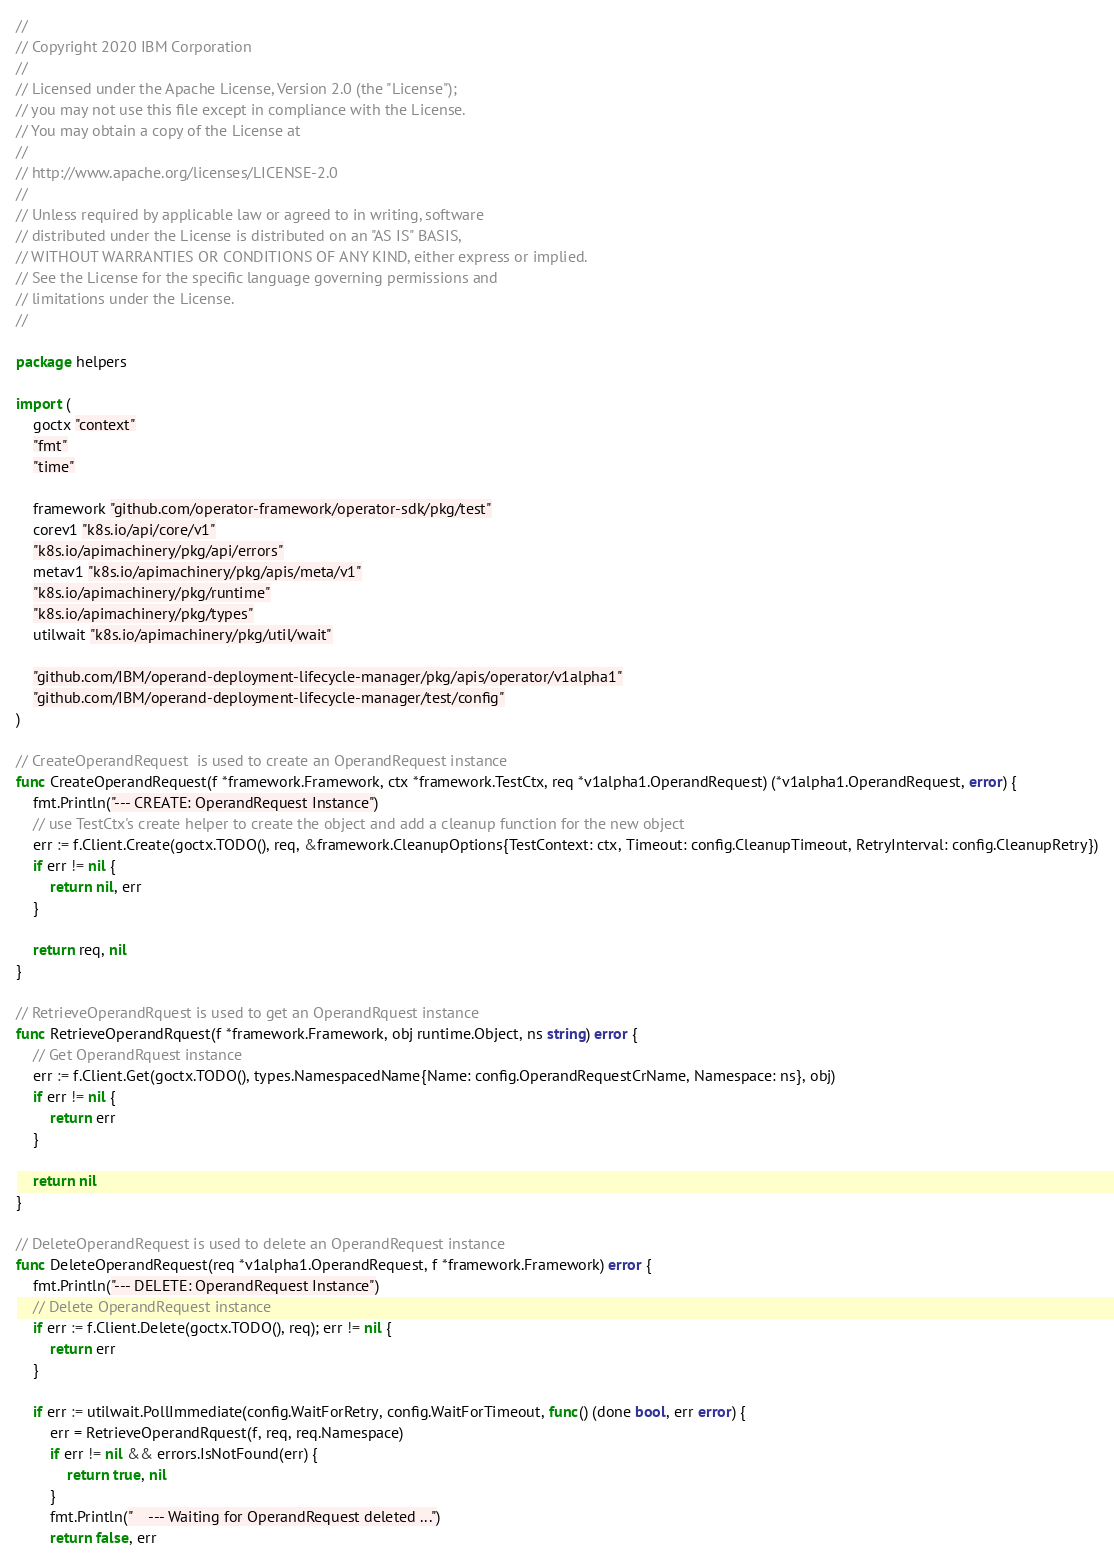Convert code to text. <code><loc_0><loc_0><loc_500><loc_500><_Go_>//
// Copyright 2020 IBM Corporation
//
// Licensed under the Apache License, Version 2.0 (the "License");
// you may not use this file except in compliance with the License.
// You may obtain a copy of the License at
//
// http://www.apache.org/licenses/LICENSE-2.0
//
// Unless required by applicable law or agreed to in writing, software
// distributed under the License is distributed on an "AS IS" BASIS,
// WITHOUT WARRANTIES OR CONDITIONS OF ANY KIND, either express or implied.
// See the License for the specific language governing permissions and
// limitations under the License.
//

package helpers

import (
	goctx "context"
	"fmt"
	"time"

	framework "github.com/operator-framework/operator-sdk/pkg/test"
	corev1 "k8s.io/api/core/v1"
	"k8s.io/apimachinery/pkg/api/errors"
	metav1 "k8s.io/apimachinery/pkg/apis/meta/v1"
	"k8s.io/apimachinery/pkg/runtime"
	"k8s.io/apimachinery/pkg/types"
	utilwait "k8s.io/apimachinery/pkg/util/wait"

	"github.com/IBM/operand-deployment-lifecycle-manager/pkg/apis/operator/v1alpha1"
	"github.com/IBM/operand-deployment-lifecycle-manager/test/config"
)

// CreateOperandRequest  is used to create an OperandRequest instance
func CreateOperandRequest(f *framework.Framework, ctx *framework.TestCtx, req *v1alpha1.OperandRequest) (*v1alpha1.OperandRequest, error) {
	fmt.Println("--- CREATE: OperandRequest Instance")
	// use TestCtx's create helper to create the object and add a cleanup function for the new object
	err := f.Client.Create(goctx.TODO(), req, &framework.CleanupOptions{TestContext: ctx, Timeout: config.CleanupTimeout, RetryInterval: config.CleanupRetry})
	if err != nil {
		return nil, err
	}

	return req, nil
}

// RetrieveOperandRquest is used to get an OperandRquest instance
func RetrieveOperandRquest(f *framework.Framework, obj runtime.Object, ns string) error {
	// Get OperandRquest instance
	err := f.Client.Get(goctx.TODO(), types.NamespacedName{Name: config.OperandRequestCrName, Namespace: ns}, obj)
	if err != nil {
		return err
	}

	return nil
}

// DeleteOperandRequest is used to delete an OperandRequest instance
func DeleteOperandRequest(req *v1alpha1.OperandRequest, f *framework.Framework) error {
	fmt.Println("--- DELETE: OperandRequest Instance")
	// Delete OperandRequest instance
	if err := f.Client.Delete(goctx.TODO(), req); err != nil {
		return err
	}

	if err := utilwait.PollImmediate(config.WaitForRetry, config.WaitForTimeout, func() (done bool, err error) {
		err = RetrieveOperandRquest(f, req, req.Namespace)
		if err != nil && errors.IsNotFound(err) {
			return true, nil
		}
		fmt.Println("    --- Waiting for OperandRequest deleted ...")
		return false, err</code> 